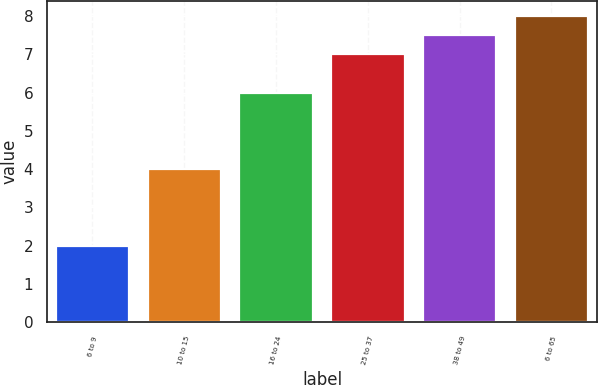<chart> <loc_0><loc_0><loc_500><loc_500><bar_chart><fcel>6 to 9<fcel>10 to 15<fcel>16 to 24<fcel>25 to 37<fcel>38 to 49<fcel>6 to 65<nl><fcel>2<fcel>4<fcel>6<fcel>7<fcel>7.5<fcel>8<nl></chart> 